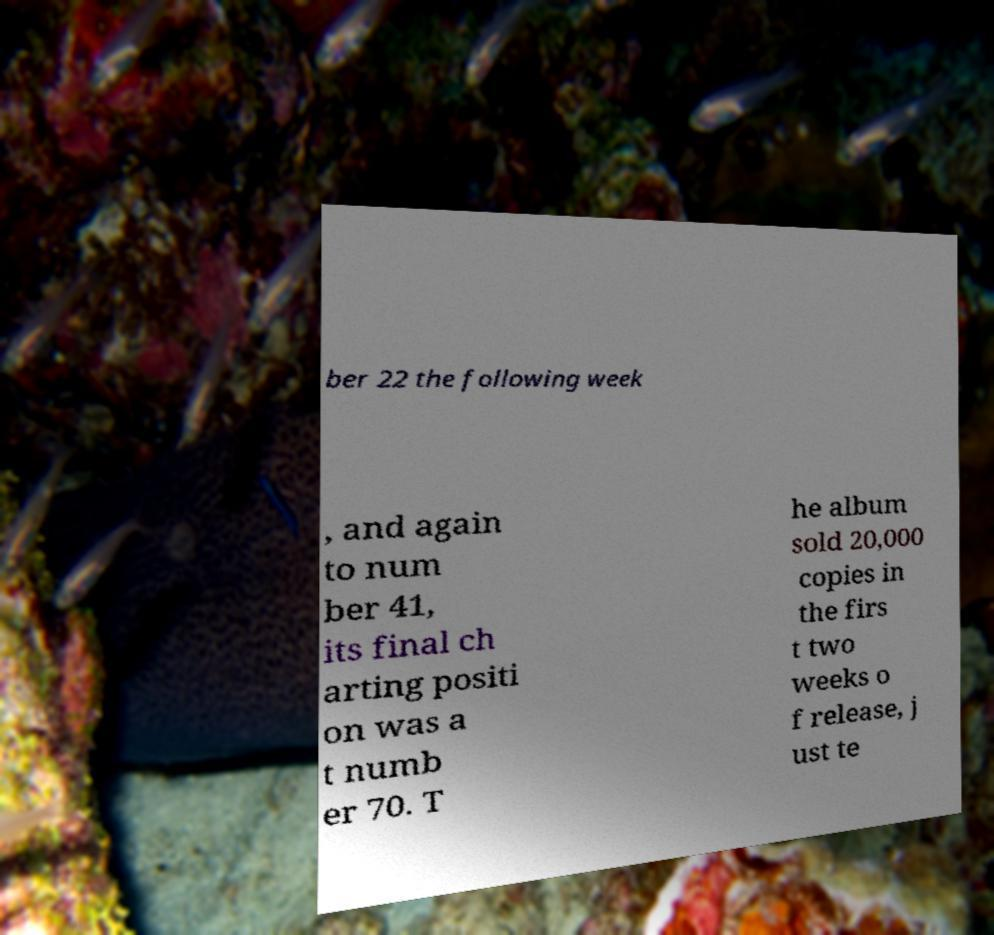Could you extract and type out the text from this image? ber 22 the following week , and again to num ber 41, its final ch arting positi on was a t numb er 70. T he album sold 20,000 copies in the firs t two weeks o f release, j ust te 